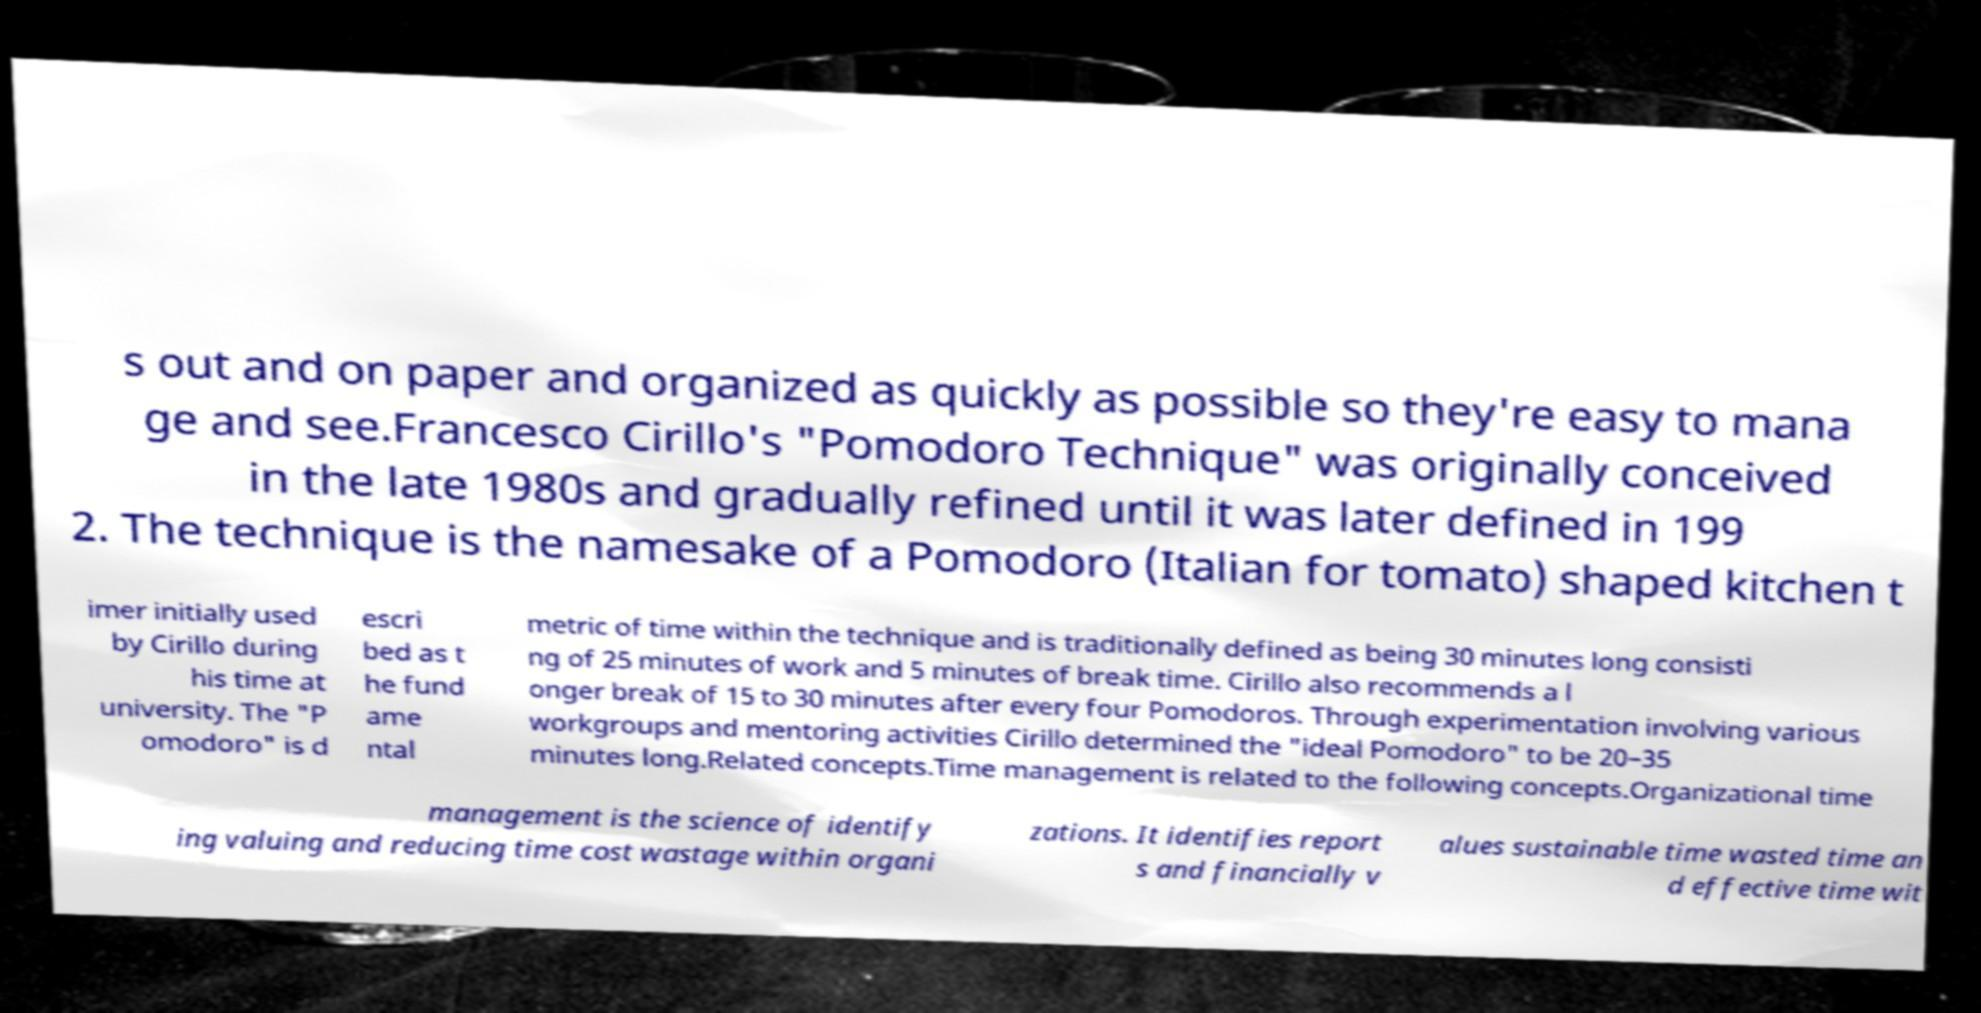Can you read and provide the text displayed in the image?This photo seems to have some interesting text. Can you extract and type it out for me? s out and on paper and organized as quickly as possible so they're easy to mana ge and see.Francesco Cirillo's "Pomodoro Technique" was originally conceived in the late 1980s and gradually refined until it was later defined in 199 2. The technique is the namesake of a Pomodoro (Italian for tomato) shaped kitchen t imer initially used by Cirillo during his time at university. The "P omodoro" is d escri bed as t he fund ame ntal metric of time within the technique and is traditionally defined as being 30 minutes long consisti ng of 25 minutes of work and 5 minutes of break time. Cirillo also recommends a l onger break of 15 to 30 minutes after every four Pomodoros. Through experimentation involving various workgroups and mentoring activities Cirillo determined the "ideal Pomodoro" to be 20–35 minutes long.Related concepts.Time management is related to the following concepts.Organizational time management is the science of identify ing valuing and reducing time cost wastage within organi zations. It identifies report s and financially v alues sustainable time wasted time an d effective time wit 